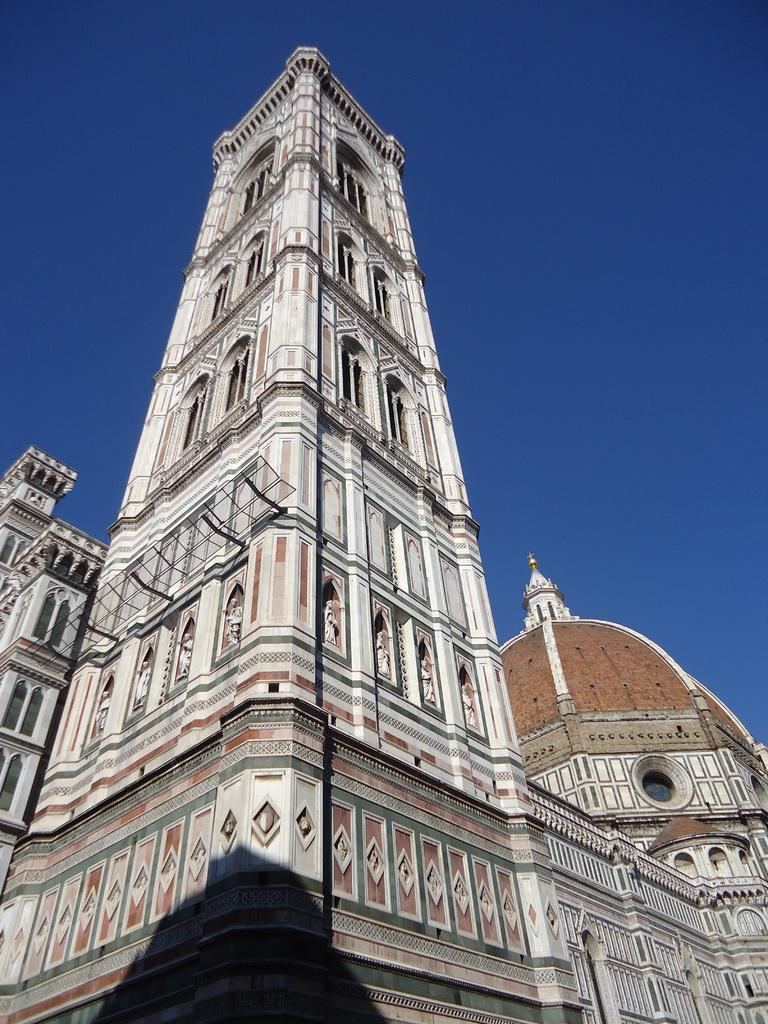What structures are present in the image? There are buildings in the image. What can be seen in the background of the image? The sky is visible in the background of the image. What type of swing can be seen in the image? There is no swing present in the image. What theory is being discussed in the image? There is no discussion or theory present in the image; it simply buildings and the sky are visible. 